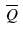<formula> <loc_0><loc_0><loc_500><loc_500>\overline { Q }</formula> 